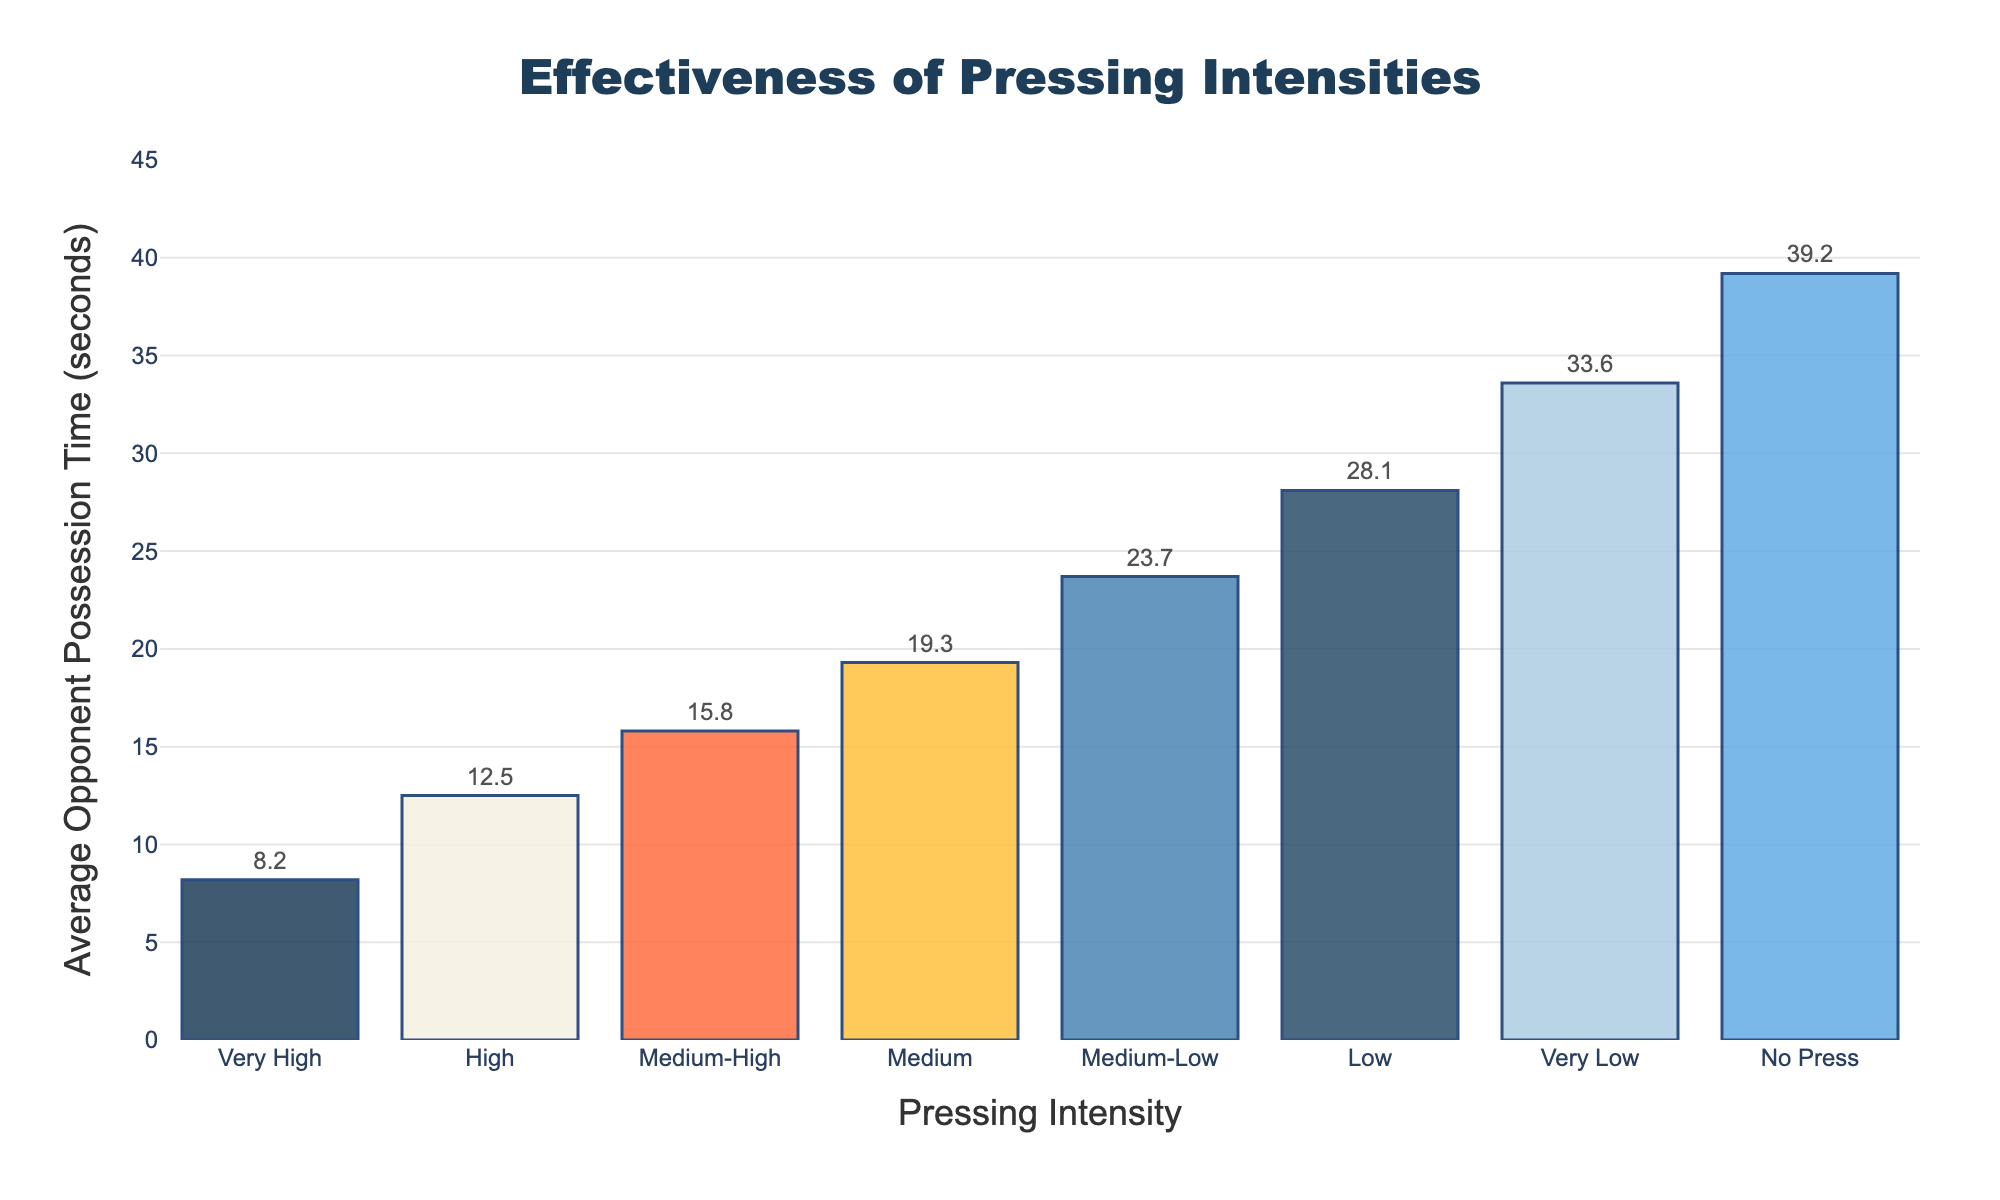Which pressing intensity has the shortest average opponent possession time? The bar chart lists different pressing intensities along the x-axis and their corresponding average opponent possession times on the y-axis. The shortest bar represents the "Very High" pressing intensity with an average possession time of 8.2 seconds.
Answer: Very High Which pressing intensity has the longest average opponent possession time? To find the longest average possession time, look for the tallest bar on the chart. The "No Press" intensity has the highest average opponent possession time of 39.2 seconds.
Answer: No Press How much longer is the average opponent possession time for "Low" pressing intensity compared to "Very High" pressing intensity? The average possession time for "Very High" pressing intensity is 8.2 seconds, and for "Low" pressing intensity is 28.1 seconds. The difference is calculated as 28.1 - 8.2.
Answer: 19.9 seconds What is the combined average opponent possession time for "Medium" and "Medium-High" pressing intensities? The average possession times for "Medium" and "Medium-High" pressing intensities are 19.3 seconds and 15.8 seconds, respectively. Combined, it’s 19.3 + 15.8.
Answer: 35.1 seconds How does the average opponent possession time for "High" pressing intensity compare to "Medium-Low"? The average opponent possession time for "High" pressing intensity is 12.5 seconds, while for "Medium-Low" pressing intensity, it is 23.7 seconds. 12.5 is less than 23.7.
Answer: High is less than Medium-Low Which pressing intensity category resides in the middle range of the chart and its corresponding average time? To find the middle range, visually identify the bar approximately in the center. "Medium" pressing intensity is in the middle range with an average opponent possession time of 19.3 seconds.
Answer: Medium What is the difference between the average opponent possession times of "Medium-High" and "Medium-Low"? The average possession times are 15.8 seconds for "Medium-High" and 23.7 seconds for "Medium-Low". The difference is calculated as 23.7 - 15.8.
Answer: 7.9 seconds What color represents the bar for "Very Low" pressing intensity? The bar for "Very Low" pressing intensity appears in a distinct color among the other bars on the chart. It is represented in light blue.
Answer: Light Blue 